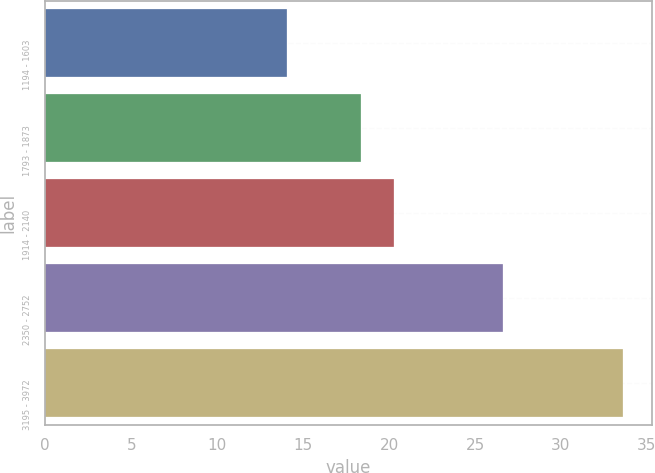<chart> <loc_0><loc_0><loc_500><loc_500><bar_chart><fcel>1194 - 1603<fcel>1793 - 1873<fcel>1914 - 2140<fcel>2350 - 2752<fcel>3195 - 3972<nl><fcel>14.09<fcel>18.35<fcel>20.3<fcel>26.64<fcel>33.59<nl></chart> 